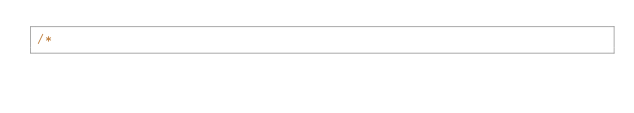Convert code to text. <code><loc_0><loc_0><loc_500><loc_500><_Cuda_>/*</code> 